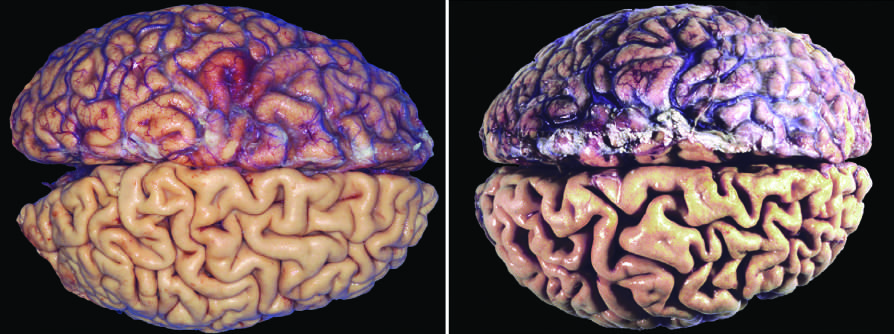s reversible injury caused by aging and reduced blood supply?
Answer the question using a single word or phrase. No 